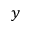<formula> <loc_0><loc_0><loc_500><loc_500>y</formula> 